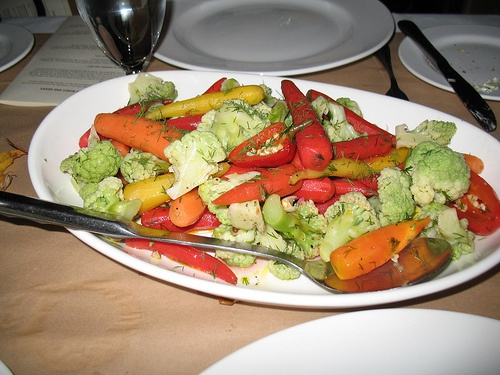Describe the objects in this image and their specific colors. I can see dining table in black, tan, gray, and maroon tones, spoon in black, brown, olive, and gray tones, carrot in black, brown, maroon, red, and olive tones, wine glass in black and gray tones, and broccoli in black, olive, and khaki tones in this image. 